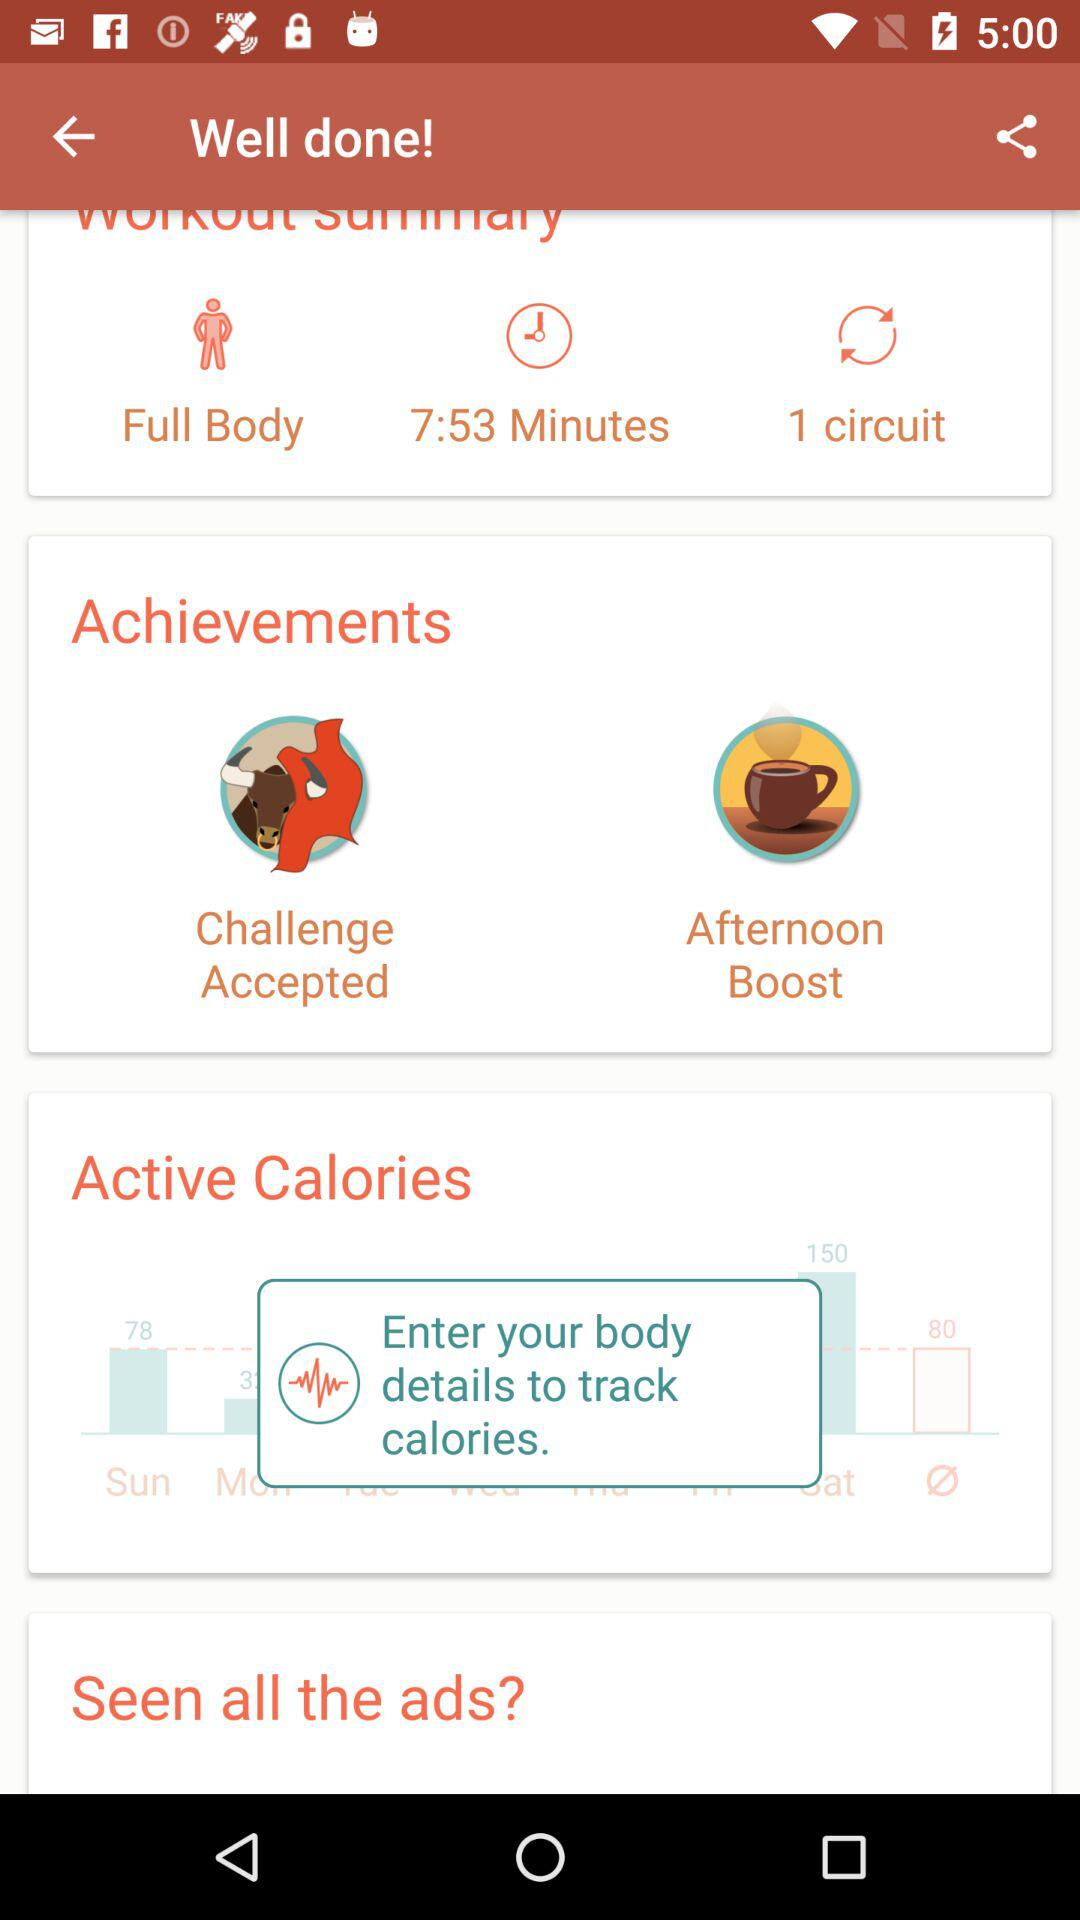How long was the workout? The workout was 7 minutes 53 seconds long. 